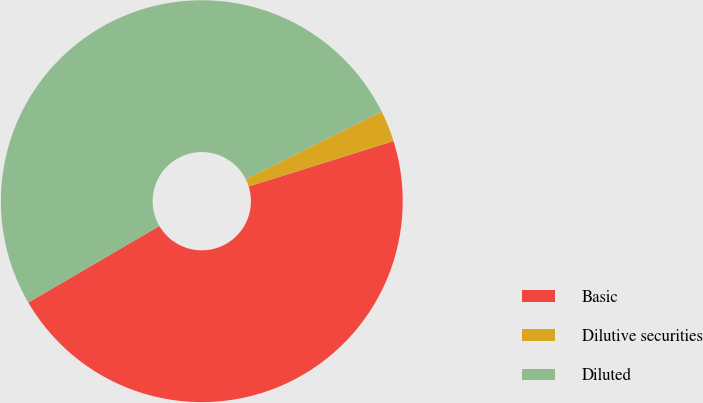Convert chart. <chart><loc_0><loc_0><loc_500><loc_500><pie_chart><fcel>Basic<fcel>Dilutive securities<fcel>Diluted<nl><fcel>46.42%<fcel>2.52%<fcel>51.06%<nl></chart> 